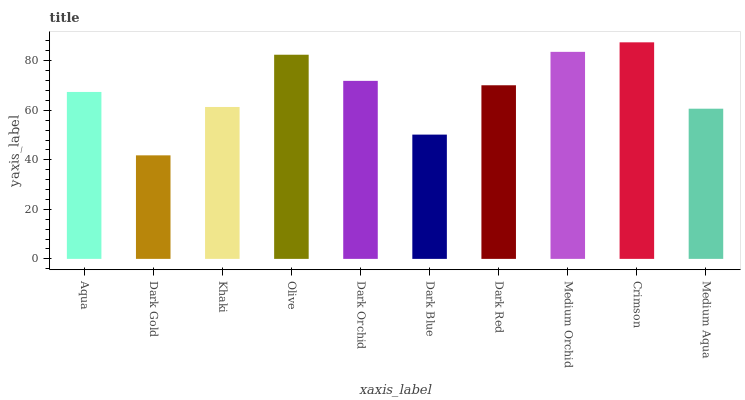Is Dark Gold the minimum?
Answer yes or no. Yes. Is Crimson the maximum?
Answer yes or no. Yes. Is Khaki the minimum?
Answer yes or no. No. Is Khaki the maximum?
Answer yes or no. No. Is Khaki greater than Dark Gold?
Answer yes or no. Yes. Is Dark Gold less than Khaki?
Answer yes or no. Yes. Is Dark Gold greater than Khaki?
Answer yes or no. No. Is Khaki less than Dark Gold?
Answer yes or no. No. Is Dark Red the high median?
Answer yes or no. Yes. Is Aqua the low median?
Answer yes or no. Yes. Is Dark Gold the high median?
Answer yes or no. No. Is Medium Orchid the low median?
Answer yes or no. No. 